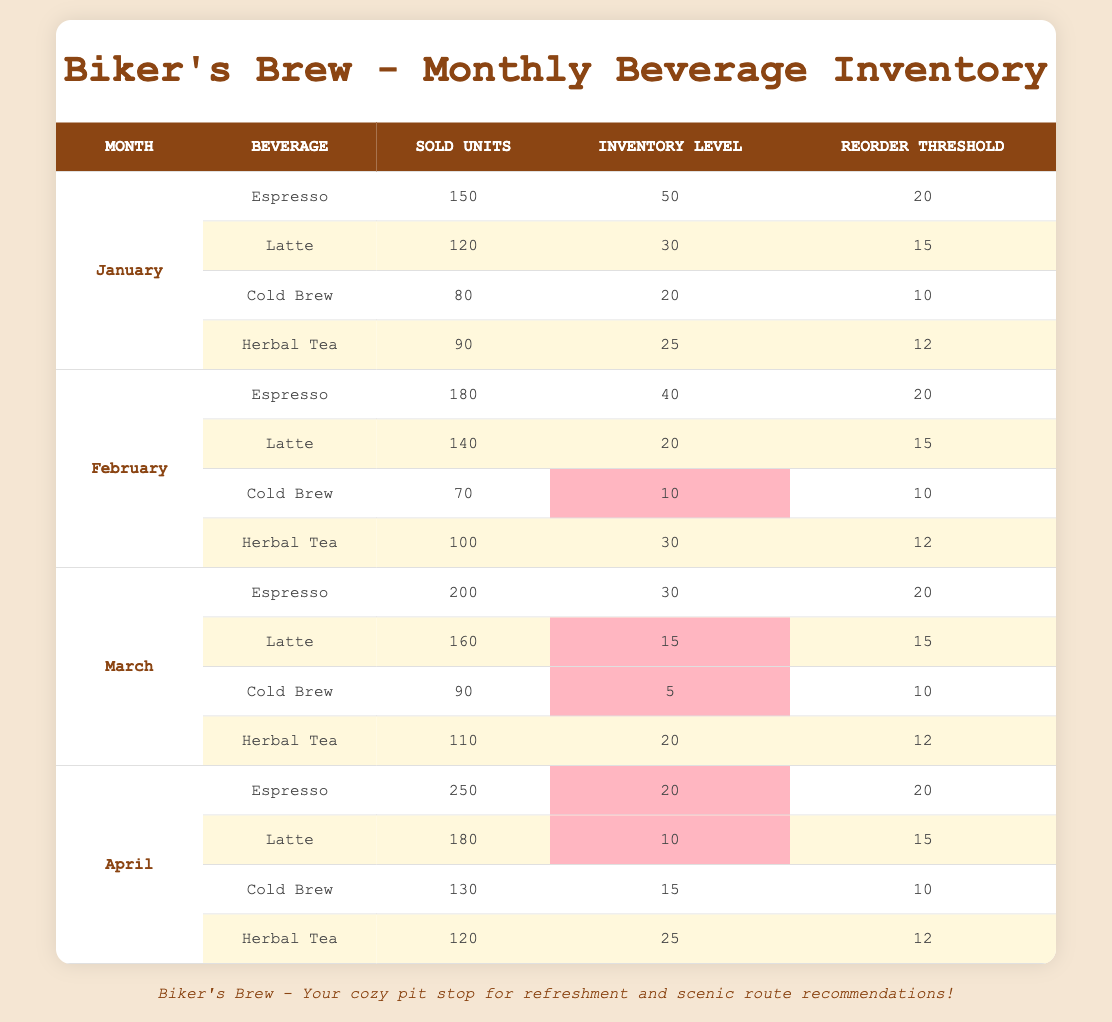What was the highest number of units sold for espresso? The highest units sold for espresso occurred in April with 250 units sold.
Answer: 250 What is the reorder threshold for cold brew in February? The reorder threshold for cold brew in February is 10.
Answer: 10 Which beverage had the lowest inventory level in March? In March, cold brew had the lowest inventory level of 5.
Answer: 5 How many total units of herbal tea were sold from January to April? The total units of herbal tea sold are 90 (January) + 100 (February) + 110 (March) + 120 (April) = 420.
Answer: 420 Is the inventory level for latte in April below its reorder threshold? In April, the inventory level for latte is 10, which is below its reorder threshold of 15.
Answer: Yes What is the average number of units sold for cold brew over the four months? The average sold units for cold brew is (80 + 70 + 90 + 130) / 4 = 270 / 4 = 67.5.
Answer: 67.5 Which month experienced the greatest increase in espresso sales compared to the previous month? The greatest increase in espresso sales occurred from March to April, increasing from 200 to 250 units, a rise of 50 units.
Answer: March to April During which month did latte reach exactly its reorder threshold for inventory? In March, the inventory level for latte was exactly at its reorder threshold of 15 units.
Answer: March How many more units of herbal tea were sold in April compared to January? The difference in units sold for herbal tea between April (120 units) and January (90 units) is 120 - 90 = 30 more units in April.
Answer: 30 What percentage of espresso sold in March exceeds its reorder threshold? In March, 200 units were sold while the reorder threshold is 20. The percentage exceeding is ((200 - 20) / 200) * 100 = 90%.
Answer: 90% 